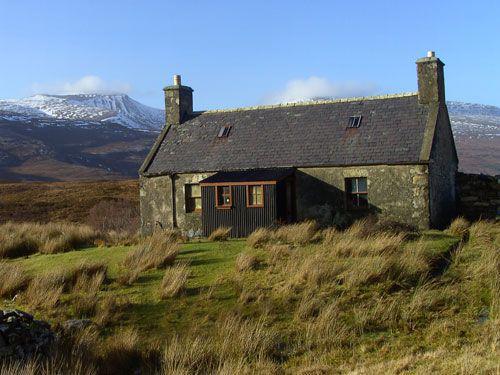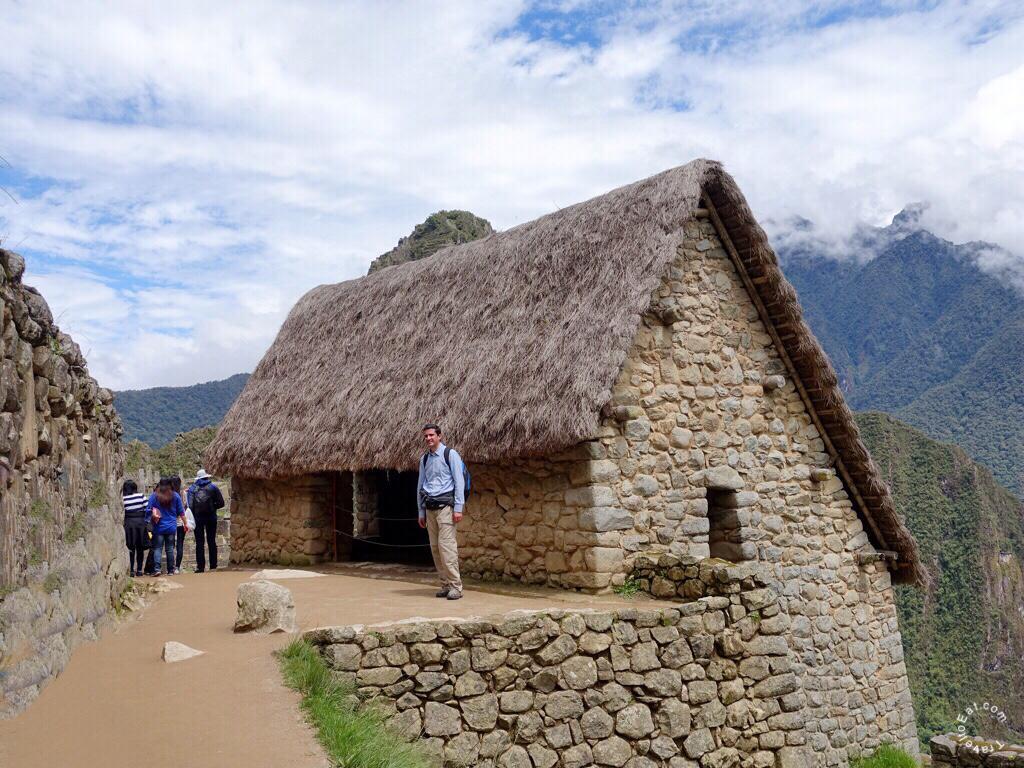The first image is the image on the left, the second image is the image on the right. Evaluate the accuracy of this statement regarding the images: "At least one person is standing on the ground outside of a building in one of the images.". Is it true? Answer yes or no. Yes. The first image is the image on the left, the second image is the image on the right. Analyze the images presented: Is the assertion "In one image, a dwelling has a thatched roof over walls made of rows of stacked rocks." valid? Answer yes or no. Yes. 